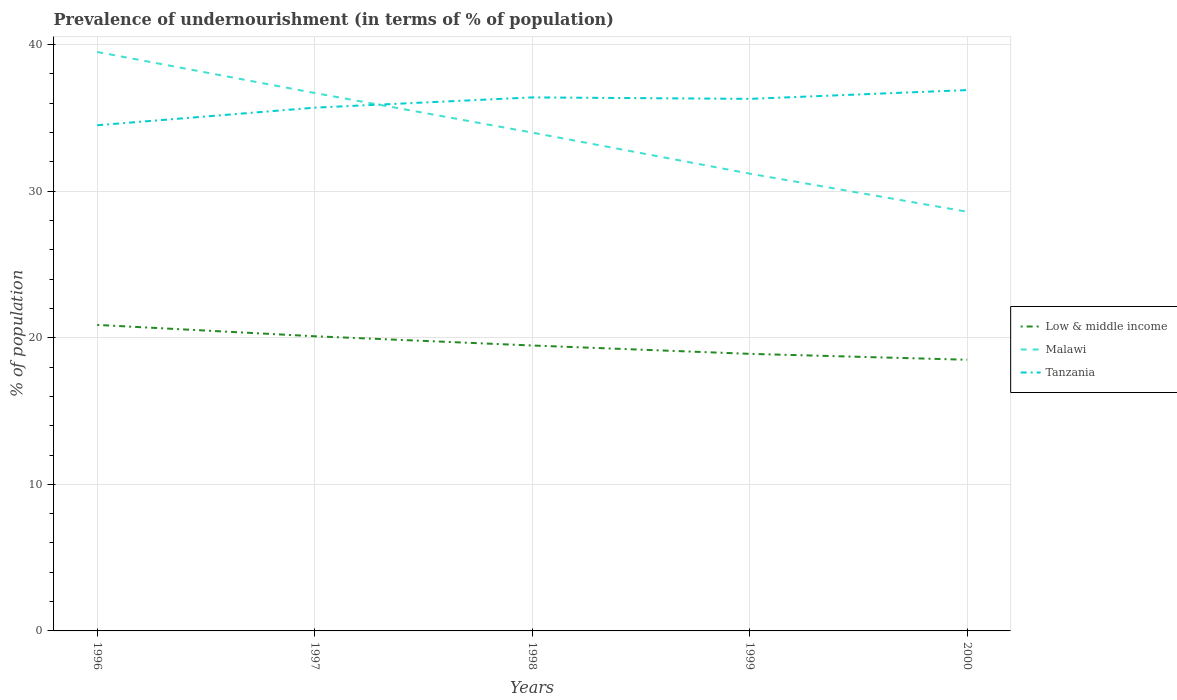How many different coloured lines are there?
Provide a short and direct response. 3. Across all years, what is the maximum percentage of undernourished population in Malawi?
Keep it short and to the point. 28.6. In which year was the percentage of undernourished population in Malawi maximum?
Make the answer very short. 2000. What is the total percentage of undernourished population in Low & middle income in the graph?
Keep it short and to the point. 1.6. What is the difference between the highest and the second highest percentage of undernourished population in Tanzania?
Offer a terse response. 2.4. Is the percentage of undernourished population in Malawi strictly greater than the percentage of undernourished population in Tanzania over the years?
Your answer should be very brief. No. How many years are there in the graph?
Keep it short and to the point. 5. Are the values on the major ticks of Y-axis written in scientific E-notation?
Your answer should be very brief. No. Does the graph contain any zero values?
Your answer should be very brief. No. Where does the legend appear in the graph?
Provide a short and direct response. Center right. How many legend labels are there?
Offer a very short reply. 3. How are the legend labels stacked?
Make the answer very short. Vertical. What is the title of the graph?
Offer a very short reply. Prevalence of undernourishment (in terms of % of population). Does "Cabo Verde" appear as one of the legend labels in the graph?
Offer a very short reply. No. What is the label or title of the X-axis?
Ensure brevity in your answer.  Years. What is the label or title of the Y-axis?
Ensure brevity in your answer.  % of population. What is the % of population of Low & middle income in 1996?
Provide a short and direct response. 20.88. What is the % of population in Malawi in 1996?
Provide a succinct answer. 39.5. What is the % of population in Tanzania in 1996?
Provide a short and direct response. 34.5. What is the % of population in Low & middle income in 1997?
Ensure brevity in your answer.  20.1. What is the % of population in Malawi in 1997?
Provide a succinct answer. 36.7. What is the % of population in Tanzania in 1997?
Ensure brevity in your answer.  35.7. What is the % of population of Low & middle income in 1998?
Ensure brevity in your answer.  19.47. What is the % of population in Tanzania in 1998?
Make the answer very short. 36.4. What is the % of population in Low & middle income in 1999?
Give a very brief answer. 18.9. What is the % of population of Malawi in 1999?
Keep it short and to the point. 31.2. What is the % of population in Tanzania in 1999?
Offer a very short reply. 36.3. What is the % of population in Low & middle income in 2000?
Provide a short and direct response. 18.5. What is the % of population of Malawi in 2000?
Ensure brevity in your answer.  28.6. What is the % of population of Tanzania in 2000?
Offer a very short reply. 36.9. Across all years, what is the maximum % of population of Low & middle income?
Give a very brief answer. 20.88. Across all years, what is the maximum % of population of Malawi?
Your response must be concise. 39.5. Across all years, what is the maximum % of population in Tanzania?
Provide a succinct answer. 36.9. Across all years, what is the minimum % of population of Low & middle income?
Offer a very short reply. 18.5. Across all years, what is the minimum % of population in Malawi?
Provide a short and direct response. 28.6. Across all years, what is the minimum % of population of Tanzania?
Offer a terse response. 34.5. What is the total % of population in Low & middle income in the graph?
Your response must be concise. 97.86. What is the total % of population of Malawi in the graph?
Ensure brevity in your answer.  170. What is the total % of population of Tanzania in the graph?
Your answer should be compact. 179.8. What is the difference between the % of population in Low & middle income in 1996 and that in 1997?
Ensure brevity in your answer.  0.77. What is the difference between the % of population of Tanzania in 1996 and that in 1997?
Give a very brief answer. -1.2. What is the difference between the % of population in Low & middle income in 1996 and that in 1998?
Provide a succinct answer. 1.41. What is the difference between the % of population of Tanzania in 1996 and that in 1998?
Offer a very short reply. -1.9. What is the difference between the % of population of Low & middle income in 1996 and that in 1999?
Make the answer very short. 1.97. What is the difference between the % of population in Malawi in 1996 and that in 1999?
Provide a succinct answer. 8.3. What is the difference between the % of population in Tanzania in 1996 and that in 1999?
Give a very brief answer. -1.8. What is the difference between the % of population in Low & middle income in 1996 and that in 2000?
Your answer should be compact. 2.38. What is the difference between the % of population in Tanzania in 1996 and that in 2000?
Keep it short and to the point. -2.4. What is the difference between the % of population in Low & middle income in 1997 and that in 1998?
Offer a very short reply. 0.63. What is the difference between the % of population of Low & middle income in 1997 and that in 1999?
Make the answer very short. 1.2. What is the difference between the % of population in Malawi in 1997 and that in 1999?
Make the answer very short. 5.5. What is the difference between the % of population of Low & middle income in 1997 and that in 2000?
Provide a short and direct response. 1.6. What is the difference between the % of population of Tanzania in 1997 and that in 2000?
Your response must be concise. -1.2. What is the difference between the % of population of Low & middle income in 1998 and that in 1999?
Your response must be concise. 0.57. What is the difference between the % of population in Malawi in 1998 and that in 1999?
Make the answer very short. 2.8. What is the difference between the % of population of Tanzania in 1998 and that in 1999?
Your answer should be compact. 0.1. What is the difference between the % of population of Low & middle income in 1998 and that in 2000?
Give a very brief answer. 0.97. What is the difference between the % of population of Malawi in 1998 and that in 2000?
Keep it short and to the point. 5.4. What is the difference between the % of population of Tanzania in 1998 and that in 2000?
Make the answer very short. -0.5. What is the difference between the % of population in Low & middle income in 1999 and that in 2000?
Your answer should be compact. 0.4. What is the difference between the % of population of Malawi in 1999 and that in 2000?
Offer a terse response. 2.6. What is the difference between the % of population in Tanzania in 1999 and that in 2000?
Your answer should be very brief. -0.6. What is the difference between the % of population in Low & middle income in 1996 and the % of population in Malawi in 1997?
Give a very brief answer. -15.82. What is the difference between the % of population in Low & middle income in 1996 and the % of population in Tanzania in 1997?
Offer a terse response. -14.82. What is the difference between the % of population of Low & middle income in 1996 and the % of population of Malawi in 1998?
Give a very brief answer. -13.12. What is the difference between the % of population in Low & middle income in 1996 and the % of population in Tanzania in 1998?
Provide a succinct answer. -15.52. What is the difference between the % of population of Low & middle income in 1996 and the % of population of Malawi in 1999?
Make the answer very short. -10.32. What is the difference between the % of population in Low & middle income in 1996 and the % of population in Tanzania in 1999?
Keep it short and to the point. -15.42. What is the difference between the % of population in Low & middle income in 1996 and the % of population in Malawi in 2000?
Your response must be concise. -7.72. What is the difference between the % of population in Low & middle income in 1996 and the % of population in Tanzania in 2000?
Keep it short and to the point. -16.02. What is the difference between the % of population of Low & middle income in 1997 and the % of population of Malawi in 1998?
Your response must be concise. -13.9. What is the difference between the % of population of Low & middle income in 1997 and the % of population of Tanzania in 1998?
Provide a short and direct response. -16.3. What is the difference between the % of population in Low & middle income in 1997 and the % of population in Malawi in 1999?
Your answer should be very brief. -11.1. What is the difference between the % of population in Low & middle income in 1997 and the % of population in Tanzania in 1999?
Keep it short and to the point. -16.2. What is the difference between the % of population of Low & middle income in 1997 and the % of population of Malawi in 2000?
Ensure brevity in your answer.  -8.5. What is the difference between the % of population in Low & middle income in 1997 and the % of population in Tanzania in 2000?
Ensure brevity in your answer.  -16.8. What is the difference between the % of population in Low & middle income in 1998 and the % of population in Malawi in 1999?
Your answer should be compact. -11.73. What is the difference between the % of population of Low & middle income in 1998 and the % of population of Tanzania in 1999?
Provide a short and direct response. -16.83. What is the difference between the % of population in Low & middle income in 1998 and the % of population in Malawi in 2000?
Offer a terse response. -9.13. What is the difference between the % of population of Low & middle income in 1998 and the % of population of Tanzania in 2000?
Give a very brief answer. -17.43. What is the difference between the % of population in Low & middle income in 1999 and the % of population in Malawi in 2000?
Provide a succinct answer. -9.7. What is the difference between the % of population of Low & middle income in 1999 and the % of population of Tanzania in 2000?
Offer a very short reply. -18. What is the average % of population in Low & middle income per year?
Provide a short and direct response. 19.57. What is the average % of population in Malawi per year?
Give a very brief answer. 34. What is the average % of population in Tanzania per year?
Your answer should be very brief. 35.96. In the year 1996, what is the difference between the % of population of Low & middle income and % of population of Malawi?
Provide a short and direct response. -18.62. In the year 1996, what is the difference between the % of population of Low & middle income and % of population of Tanzania?
Provide a short and direct response. -13.62. In the year 1997, what is the difference between the % of population of Low & middle income and % of population of Malawi?
Offer a very short reply. -16.6. In the year 1997, what is the difference between the % of population of Low & middle income and % of population of Tanzania?
Your answer should be very brief. -15.6. In the year 1997, what is the difference between the % of population of Malawi and % of population of Tanzania?
Provide a succinct answer. 1. In the year 1998, what is the difference between the % of population of Low & middle income and % of population of Malawi?
Give a very brief answer. -14.53. In the year 1998, what is the difference between the % of population in Low & middle income and % of population in Tanzania?
Ensure brevity in your answer.  -16.93. In the year 1998, what is the difference between the % of population in Malawi and % of population in Tanzania?
Your answer should be very brief. -2.4. In the year 1999, what is the difference between the % of population of Low & middle income and % of population of Malawi?
Ensure brevity in your answer.  -12.3. In the year 1999, what is the difference between the % of population in Low & middle income and % of population in Tanzania?
Offer a very short reply. -17.4. In the year 2000, what is the difference between the % of population of Low & middle income and % of population of Malawi?
Provide a succinct answer. -10.1. In the year 2000, what is the difference between the % of population in Low & middle income and % of population in Tanzania?
Provide a short and direct response. -18.4. What is the ratio of the % of population in Malawi in 1996 to that in 1997?
Your answer should be very brief. 1.08. What is the ratio of the % of population of Tanzania in 1996 to that in 1997?
Provide a short and direct response. 0.97. What is the ratio of the % of population of Low & middle income in 1996 to that in 1998?
Your answer should be compact. 1.07. What is the ratio of the % of population of Malawi in 1996 to that in 1998?
Keep it short and to the point. 1.16. What is the ratio of the % of population in Tanzania in 1996 to that in 1998?
Offer a very short reply. 0.95. What is the ratio of the % of population in Low & middle income in 1996 to that in 1999?
Give a very brief answer. 1.1. What is the ratio of the % of population in Malawi in 1996 to that in 1999?
Offer a terse response. 1.27. What is the ratio of the % of population in Tanzania in 1996 to that in 1999?
Ensure brevity in your answer.  0.95. What is the ratio of the % of population in Low & middle income in 1996 to that in 2000?
Your response must be concise. 1.13. What is the ratio of the % of population of Malawi in 1996 to that in 2000?
Offer a very short reply. 1.38. What is the ratio of the % of population in Tanzania in 1996 to that in 2000?
Your answer should be very brief. 0.94. What is the ratio of the % of population in Low & middle income in 1997 to that in 1998?
Provide a short and direct response. 1.03. What is the ratio of the % of population of Malawi in 1997 to that in 1998?
Provide a short and direct response. 1.08. What is the ratio of the % of population of Tanzania in 1997 to that in 1998?
Offer a terse response. 0.98. What is the ratio of the % of population of Low & middle income in 1997 to that in 1999?
Offer a terse response. 1.06. What is the ratio of the % of population in Malawi in 1997 to that in 1999?
Your response must be concise. 1.18. What is the ratio of the % of population of Tanzania in 1997 to that in 1999?
Offer a terse response. 0.98. What is the ratio of the % of population in Low & middle income in 1997 to that in 2000?
Your answer should be compact. 1.09. What is the ratio of the % of population of Malawi in 1997 to that in 2000?
Offer a very short reply. 1.28. What is the ratio of the % of population of Tanzania in 1997 to that in 2000?
Make the answer very short. 0.97. What is the ratio of the % of population of Low & middle income in 1998 to that in 1999?
Keep it short and to the point. 1.03. What is the ratio of the % of population of Malawi in 1998 to that in 1999?
Your answer should be compact. 1.09. What is the ratio of the % of population in Tanzania in 1998 to that in 1999?
Give a very brief answer. 1. What is the ratio of the % of population of Low & middle income in 1998 to that in 2000?
Ensure brevity in your answer.  1.05. What is the ratio of the % of population of Malawi in 1998 to that in 2000?
Make the answer very short. 1.19. What is the ratio of the % of population of Tanzania in 1998 to that in 2000?
Your answer should be compact. 0.99. What is the ratio of the % of population of Low & middle income in 1999 to that in 2000?
Provide a succinct answer. 1.02. What is the ratio of the % of population of Malawi in 1999 to that in 2000?
Ensure brevity in your answer.  1.09. What is the ratio of the % of population of Tanzania in 1999 to that in 2000?
Provide a succinct answer. 0.98. What is the difference between the highest and the second highest % of population of Low & middle income?
Offer a terse response. 0.77. What is the difference between the highest and the second highest % of population in Malawi?
Make the answer very short. 2.8. What is the difference between the highest and the lowest % of population in Low & middle income?
Your response must be concise. 2.38. What is the difference between the highest and the lowest % of population in Tanzania?
Your response must be concise. 2.4. 